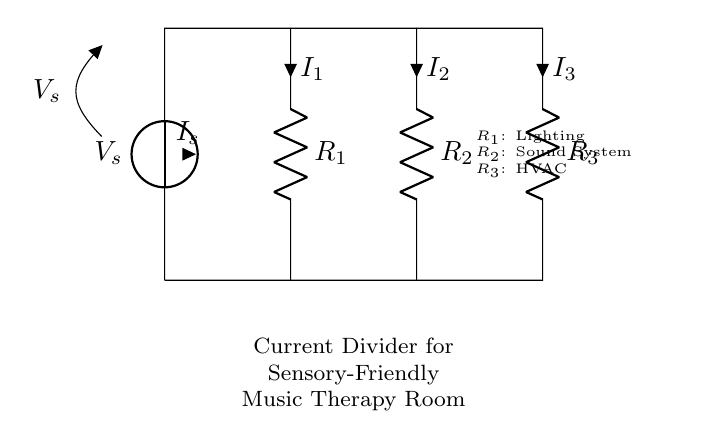What is the source voltage in this circuit? The circuit has a voltage source labeled as V_s, which indicates the supply voltage. The value is not given, but it is indicated as the source.
Answer: V_s What components are used in this current divider? The diagram shows three resistors labeled R_1, R_2, and R_3. These resistors are used to divide the current among different loads in the circuit.
Answer: R_1, R_2, R_3 Which resistor corresponds to the lighting in the music therapy room? The circuit notes that R_1 is associated with lighting, indicating this resistor controls the power to the lights in the room.
Answer: R_1 How many resistors are present in this current divider? The diagram clearly shows three resistors connected in parallel, which is typical for a current divider circuit.
Answer: Three If the total current entering the circuit is I_s, how is it divided among the resistors? In a current divider, the total current I_s is divided among the resistors R_1, R_2, and R_3 based on their resistance values. The current flowing through each resistor is inversely proportional to its resistance.
Answer: Inversely proportional to resistance What is the purpose of using a current divider in a sensory-friendly music therapy room? The current divider allows for the management and distribution of power consumption to various systems like lighting, sound, and HVAC, ensuring a controlled and comfortable environment for users in therapy.
Answer: Power management 